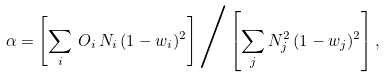<formula> <loc_0><loc_0><loc_500><loc_500>\alpha = \left [ \sum _ { i } \, O _ { i } \, N _ { i } \, ( 1 - w _ { i } ) ^ { 2 } \right ] \Big / \left [ \sum _ { j } N _ { j } ^ { 2 } \, ( 1 - w _ { j } ) ^ { 2 } \right ] ,</formula> 